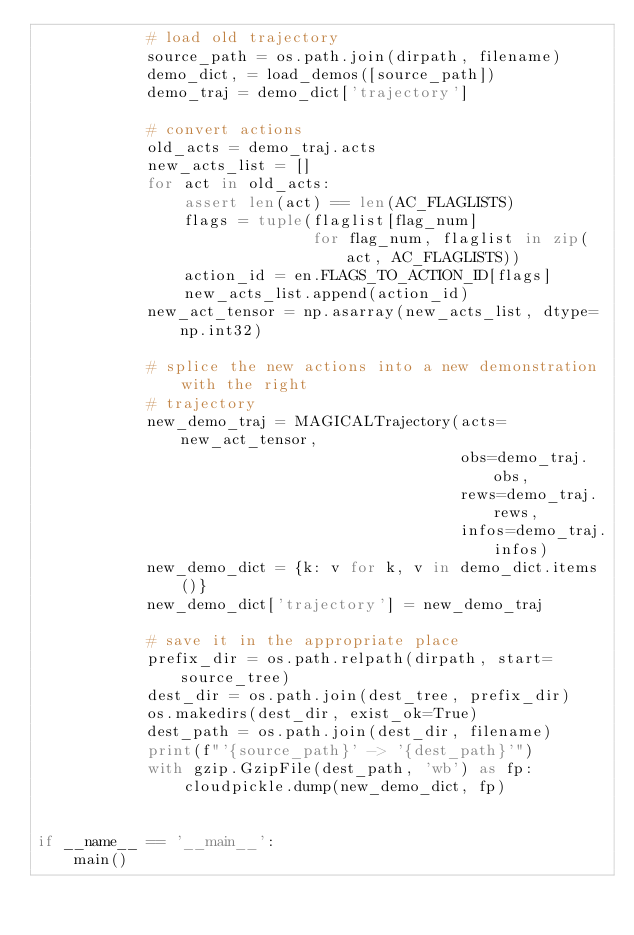<code> <loc_0><loc_0><loc_500><loc_500><_Python_>            # load old trajectory
            source_path = os.path.join(dirpath, filename)
            demo_dict, = load_demos([source_path])
            demo_traj = demo_dict['trajectory']

            # convert actions
            old_acts = demo_traj.acts
            new_acts_list = []
            for act in old_acts:
                assert len(act) == len(AC_FLAGLISTS)
                flags = tuple(flaglist[flag_num]
                              for flag_num, flaglist in zip(act, AC_FLAGLISTS))
                action_id = en.FLAGS_TO_ACTION_ID[flags]
                new_acts_list.append(action_id)
            new_act_tensor = np.asarray(new_acts_list, dtype=np.int32)

            # splice the new actions into a new demonstration with the right
            # trajectory
            new_demo_traj = MAGICALTrajectory(acts=new_act_tensor,
                                              obs=demo_traj.obs,
                                              rews=demo_traj.rews,
                                              infos=demo_traj.infos)
            new_demo_dict = {k: v for k, v in demo_dict.items()}
            new_demo_dict['trajectory'] = new_demo_traj

            # save it in the appropriate place
            prefix_dir = os.path.relpath(dirpath, start=source_tree)
            dest_dir = os.path.join(dest_tree, prefix_dir)
            os.makedirs(dest_dir, exist_ok=True)
            dest_path = os.path.join(dest_dir, filename)
            print(f"'{source_path}' -> '{dest_path}'")
            with gzip.GzipFile(dest_path, 'wb') as fp:
                cloudpickle.dump(new_demo_dict, fp)


if __name__ == '__main__':
    main()
</code> 